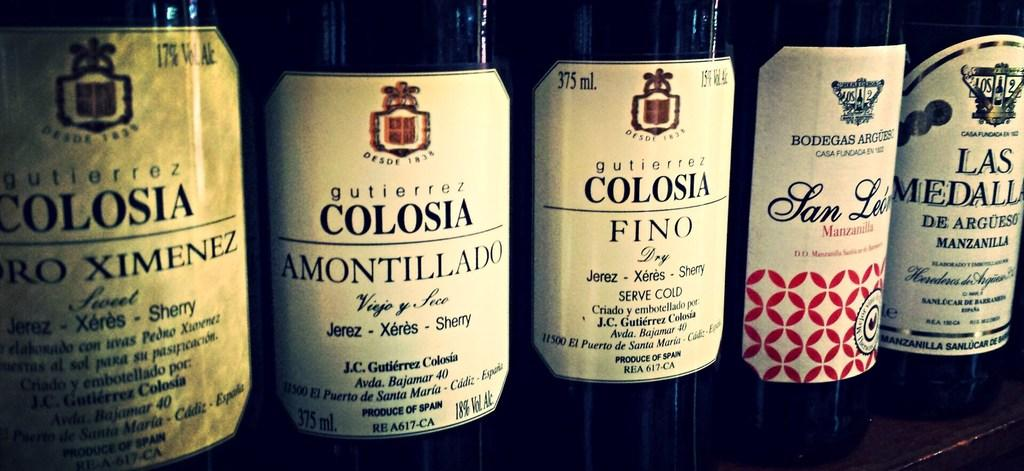What objects can be seen in the image? There are bottles in the image. What additional features can be observed on the bottles? There are stickers on the bottles. What type of ghost can be seen interacting with the bottles in the image? There is no ghost present in the image; it only features bottles with stickers. What happened to the sidewalk after the bottles were placed on it? There is no mention of a sidewalk in the image, so it is not possible to determine the aftermath of placing the bottles on it. 